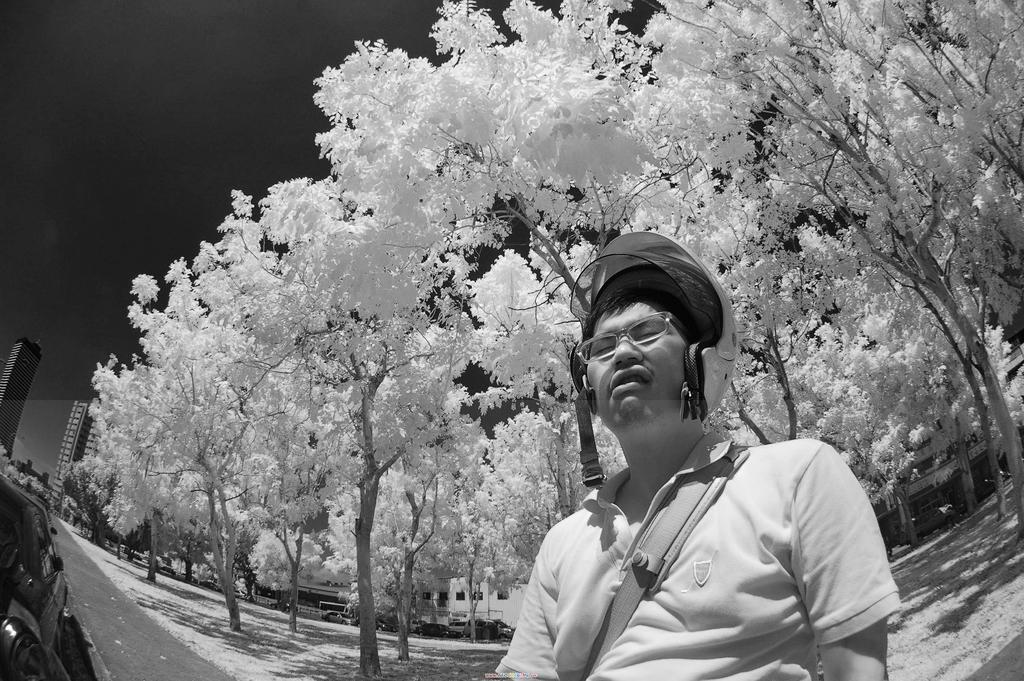What is the main subject of the image? There is a man standing in the image. What is the man wearing on his head? The man is wearing a helmet. What type of natural environment can be seen in the image? There are trees visible in the image. What type of man-made structures can be seen in the image? There are buildings visible in the image. What part of the natural environment is visible in the image? The sky is visible in the image. What type of beef is being served in the image? There is no beef present in the image; it features a man wearing a helmet with trees, buildings, and the sky visible in the background. What color is the jelly on the man's helmet in the image? There is no jelly present on the man's helmet in the image. 